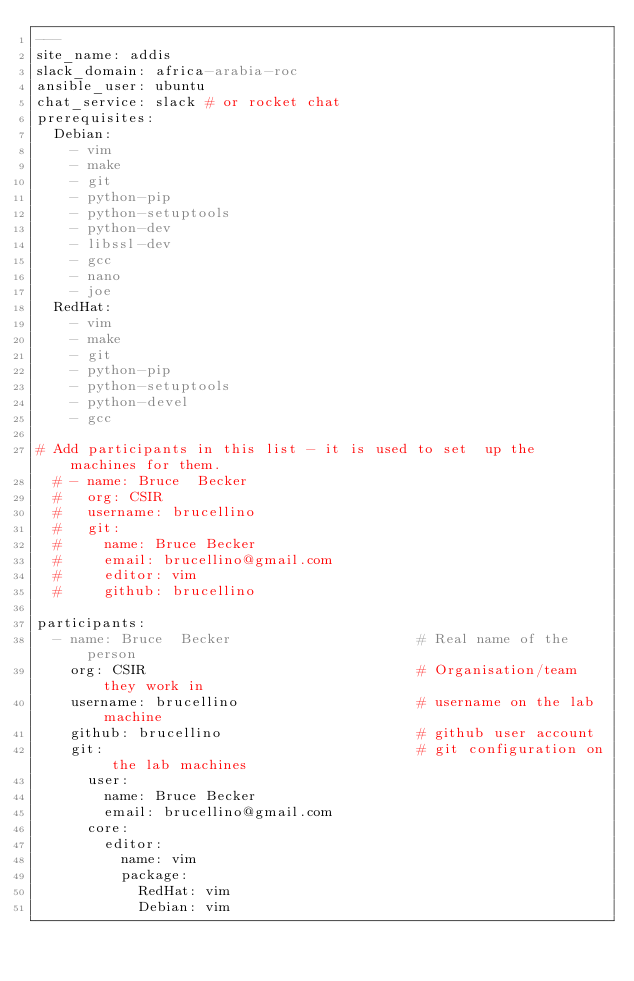<code> <loc_0><loc_0><loc_500><loc_500><_YAML_>---
site_name: addis
slack_domain: africa-arabia-roc
ansible_user: ubuntu
chat_service: slack # or rocket chat
prerequisites:
  Debian:
    - vim
    - make
    - git
    - python-pip
    - python-setuptools
    - python-dev
    - libssl-dev
    - gcc
    - nano
    - joe
  RedHat:
    - vim
    - make
    - git
    - python-pip
    - python-setuptools
    - python-devel
    - gcc

# Add participants in this list - it is used to set  up the machines for them.
  # - name: Bruce  Becker
  #   org: CSIR
  #   username: brucellino
  #   git:
  #     name: Bruce Becker
  #     email: brucellino@gmail.com
  #     editor: vim
  #     github: brucellino

participants:
  - name: Bruce  Becker                      # Real name of the person
    org: CSIR                                # Organisation/team they work in
    username: brucellino                     # username on the lab machine
    github: brucellino                       # github user account
    git:                                     # git configuration on the lab machines
      user:
        name: Bruce Becker
        email: brucellino@gmail.com
      core:
        editor:
          name: vim
          package:
            RedHat: vim
            Debian: vim
</code> 